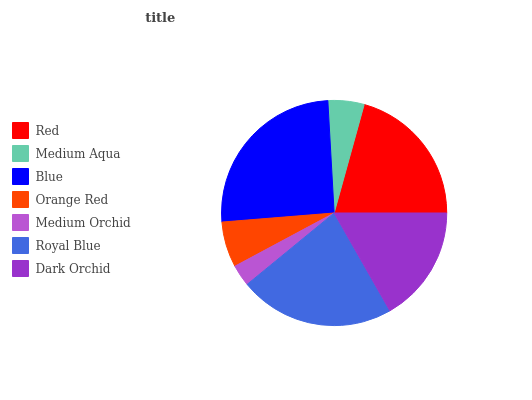Is Medium Orchid the minimum?
Answer yes or no. Yes. Is Blue the maximum?
Answer yes or no. Yes. Is Medium Aqua the minimum?
Answer yes or no. No. Is Medium Aqua the maximum?
Answer yes or no. No. Is Red greater than Medium Aqua?
Answer yes or no. Yes. Is Medium Aqua less than Red?
Answer yes or no. Yes. Is Medium Aqua greater than Red?
Answer yes or no. No. Is Red less than Medium Aqua?
Answer yes or no. No. Is Dark Orchid the high median?
Answer yes or no. Yes. Is Dark Orchid the low median?
Answer yes or no. Yes. Is Medium Aqua the high median?
Answer yes or no. No. Is Medium Orchid the low median?
Answer yes or no. No. 